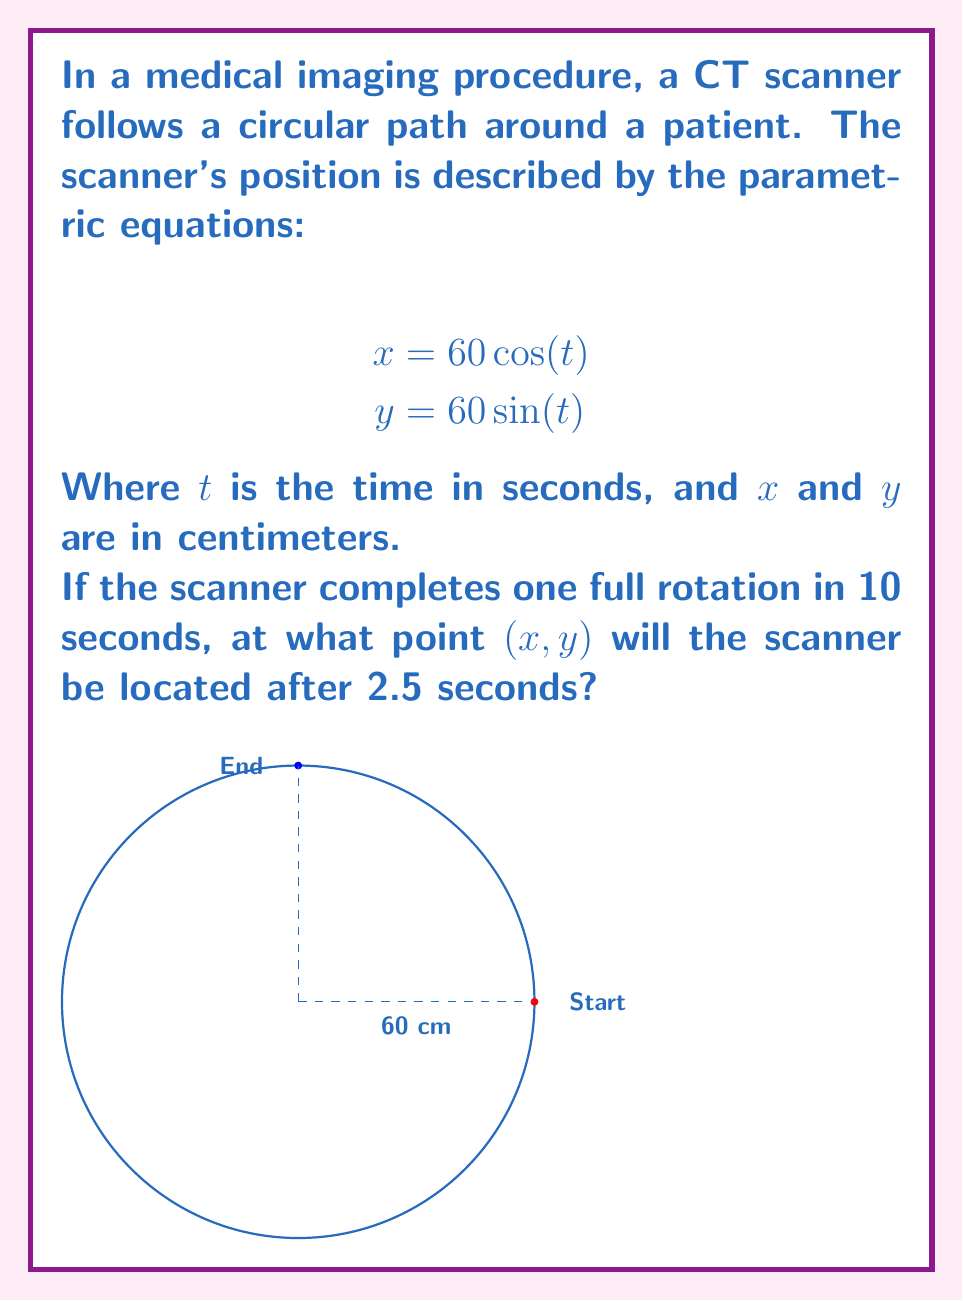Help me with this question. Let's approach this step-by-step:

1) First, we need to determine the angle $t$ after 2.5 seconds. We know that:
   - One full rotation (2π radians) takes 10 seconds
   - We want to find the angle after 2.5 seconds

2) We can set up a proportion:
   $$\frac{2\pi \text{ radians}}{10 \text{ seconds}} = \frac{t \text{ radians}}{2.5 \text{ seconds}}$$

3) Cross multiply and solve for $t$:
   $$10t = 2\pi \cdot 2.5$$
   $$t = \frac{5\pi}{10} = \frac{\pi}{2} \text{ radians}$$

4) Now that we have $t$, we can substitute it into our parametric equations:

   For x:
   $$x = 60 \cos(\frac{\pi}{2}) = 60 \cdot 0 = 0$$

   For y:
   $$y = 60 \sin(\frac{\pi}{2}) = 60 \cdot 1 = 60$$

5) Therefore, after 2.5 seconds, the scanner will be at the point (0, 60).
Answer: (0, 60) 